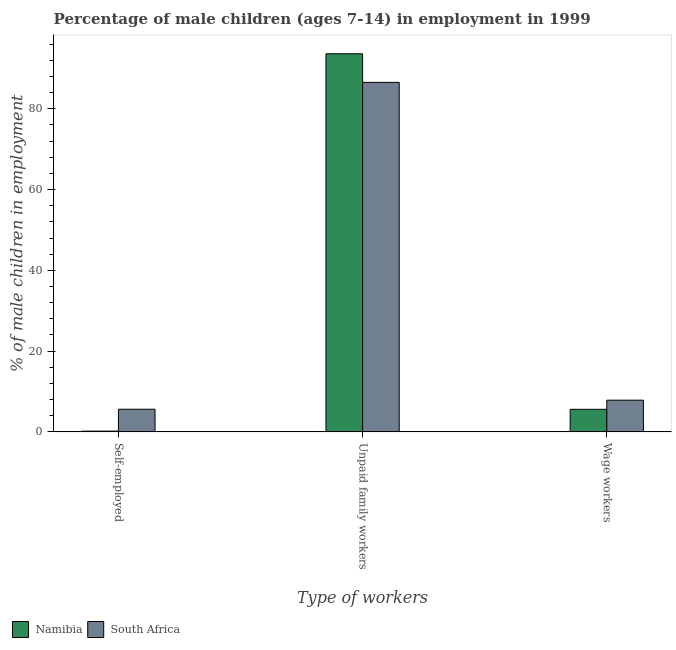How many different coloured bars are there?
Keep it short and to the point. 2. How many groups of bars are there?
Offer a terse response. 3. Are the number of bars per tick equal to the number of legend labels?
Your answer should be compact. Yes. Are the number of bars on each tick of the X-axis equal?
Offer a very short reply. Yes. What is the label of the 3rd group of bars from the left?
Make the answer very short. Wage workers. What is the percentage of children employed as wage workers in South Africa?
Offer a very short reply. 7.86. Across all countries, what is the maximum percentage of children employed as unpaid family workers?
Make the answer very short. 93.6. In which country was the percentage of children employed as wage workers maximum?
Give a very brief answer. South Africa. In which country was the percentage of self employed children minimum?
Give a very brief answer. Namibia. What is the total percentage of children employed as wage workers in the graph?
Your answer should be very brief. 13.46. What is the difference between the percentage of children employed as wage workers in South Africa and that in Namibia?
Make the answer very short. 2.26. What is the difference between the percentage of children employed as wage workers in South Africa and the percentage of self employed children in Namibia?
Make the answer very short. 7.66. What is the average percentage of self employed children per country?
Your answer should be compact. 2.91. What is the difference between the percentage of children employed as unpaid family workers and percentage of children employed as wage workers in Namibia?
Your answer should be compact. 88. What is the ratio of the percentage of self employed children in Namibia to that in South Africa?
Offer a terse response. 0.04. Is the percentage of children employed as unpaid family workers in South Africa less than that in Namibia?
Make the answer very short. Yes. What is the difference between the highest and the second highest percentage of children employed as wage workers?
Provide a short and direct response. 2.26. What is the difference between the highest and the lowest percentage of self employed children?
Your response must be concise. 5.42. In how many countries, is the percentage of self employed children greater than the average percentage of self employed children taken over all countries?
Your answer should be very brief. 1. What does the 1st bar from the left in Unpaid family workers represents?
Offer a very short reply. Namibia. What does the 2nd bar from the right in Wage workers represents?
Ensure brevity in your answer.  Namibia. Is it the case that in every country, the sum of the percentage of self employed children and percentage of children employed as unpaid family workers is greater than the percentage of children employed as wage workers?
Provide a succinct answer. Yes. How many countries are there in the graph?
Keep it short and to the point. 2. What is the difference between two consecutive major ticks on the Y-axis?
Keep it short and to the point. 20. What is the title of the graph?
Offer a very short reply. Percentage of male children (ages 7-14) in employment in 1999. Does "Ireland" appear as one of the legend labels in the graph?
Your answer should be compact. No. What is the label or title of the X-axis?
Your answer should be very brief. Type of workers. What is the label or title of the Y-axis?
Your answer should be very brief. % of male children in employment. What is the % of male children in employment in South Africa in Self-employed?
Your answer should be compact. 5.62. What is the % of male children in employment of Namibia in Unpaid family workers?
Offer a very short reply. 93.6. What is the % of male children in employment of South Africa in Unpaid family workers?
Provide a short and direct response. 86.52. What is the % of male children in employment of South Africa in Wage workers?
Your response must be concise. 7.86. Across all Type of workers, what is the maximum % of male children in employment of Namibia?
Provide a succinct answer. 93.6. Across all Type of workers, what is the maximum % of male children in employment of South Africa?
Offer a very short reply. 86.52. Across all Type of workers, what is the minimum % of male children in employment of South Africa?
Ensure brevity in your answer.  5.62. What is the total % of male children in employment of Namibia in the graph?
Provide a short and direct response. 99.4. What is the difference between the % of male children in employment of Namibia in Self-employed and that in Unpaid family workers?
Keep it short and to the point. -93.4. What is the difference between the % of male children in employment in South Africa in Self-employed and that in Unpaid family workers?
Your answer should be compact. -80.9. What is the difference between the % of male children in employment of Namibia in Self-employed and that in Wage workers?
Your answer should be very brief. -5.4. What is the difference between the % of male children in employment of South Africa in Self-employed and that in Wage workers?
Provide a short and direct response. -2.24. What is the difference between the % of male children in employment in Namibia in Unpaid family workers and that in Wage workers?
Provide a succinct answer. 88. What is the difference between the % of male children in employment of South Africa in Unpaid family workers and that in Wage workers?
Provide a short and direct response. 78.66. What is the difference between the % of male children in employment of Namibia in Self-employed and the % of male children in employment of South Africa in Unpaid family workers?
Offer a very short reply. -86.32. What is the difference between the % of male children in employment of Namibia in Self-employed and the % of male children in employment of South Africa in Wage workers?
Your answer should be compact. -7.66. What is the difference between the % of male children in employment of Namibia in Unpaid family workers and the % of male children in employment of South Africa in Wage workers?
Offer a terse response. 85.74. What is the average % of male children in employment of Namibia per Type of workers?
Ensure brevity in your answer.  33.13. What is the average % of male children in employment of South Africa per Type of workers?
Your response must be concise. 33.33. What is the difference between the % of male children in employment of Namibia and % of male children in employment of South Africa in Self-employed?
Offer a terse response. -5.42. What is the difference between the % of male children in employment of Namibia and % of male children in employment of South Africa in Unpaid family workers?
Make the answer very short. 7.08. What is the difference between the % of male children in employment of Namibia and % of male children in employment of South Africa in Wage workers?
Keep it short and to the point. -2.26. What is the ratio of the % of male children in employment of Namibia in Self-employed to that in Unpaid family workers?
Offer a terse response. 0. What is the ratio of the % of male children in employment in South Africa in Self-employed to that in Unpaid family workers?
Offer a very short reply. 0.07. What is the ratio of the % of male children in employment of Namibia in Self-employed to that in Wage workers?
Your response must be concise. 0.04. What is the ratio of the % of male children in employment of South Africa in Self-employed to that in Wage workers?
Provide a succinct answer. 0.71. What is the ratio of the % of male children in employment in Namibia in Unpaid family workers to that in Wage workers?
Keep it short and to the point. 16.71. What is the ratio of the % of male children in employment in South Africa in Unpaid family workers to that in Wage workers?
Offer a very short reply. 11.01. What is the difference between the highest and the second highest % of male children in employment in Namibia?
Keep it short and to the point. 88. What is the difference between the highest and the second highest % of male children in employment in South Africa?
Provide a succinct answer. 78.66. What is the difference between the highest and the lowest % of male children in employment in Namibia?
Give a very brief answer. 93.4. What is the difference between the highest and the lowest % of male children in employment in South Africa?
Provide a succinct answer. 80.9. 